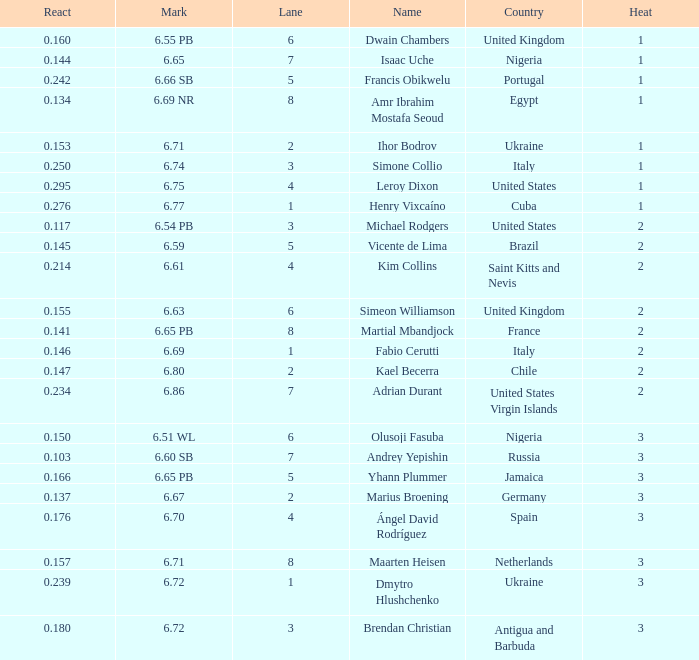What is Country, when Lane is 5, and when React is greater than 0.166? Portugal. 